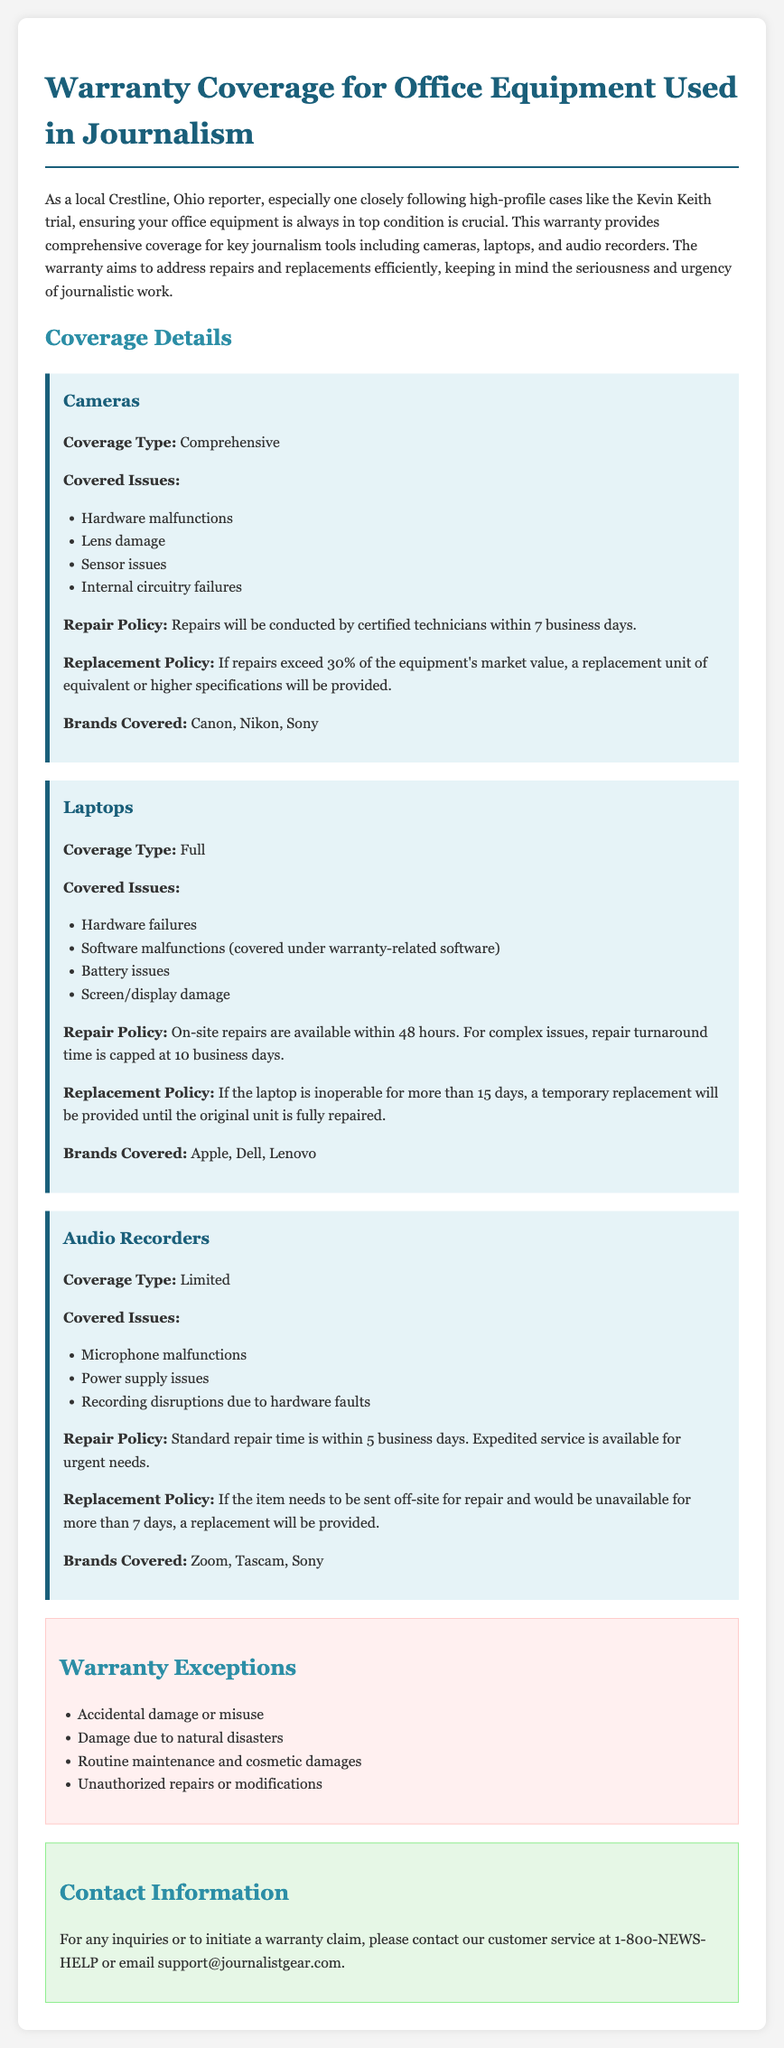what is the warranty coverage type for cameras? The document states that the coverage type for cameras is comprehensive.
Answer: comprehensive how many business days does it take for camera repairs? The repair policy for cameras mentions that repairs will be conducted within 7 business days.
Answer: 7 business days what brands are covered under the laptop warranty? The document lists the brands covered for laptops as Apple, Dell, and Lenovo.
Answer: Apple, Dell, Lenovo what is the maximum time for laptop repairs? For complex issues with laptops, the repair turnaround time is capped at 10 business days.
Answer: 10 business days how long will it take to replace a laptop if it is inoperable? The replacement policy states that a temporary replacement will be provided if the laptop is inoperable for more than 15 days.
Answer: 15 days what power supply issues are covered under audio recorders? The warranty for audio recorders covers power supply issues among other listed problems.
Answer: power supply issues what is one exception listed for the warranty coverage? The warranty exceptions include damage due to natural disasters.
Answer: damage due to natural disasters who should be contacted for warranty claims? For warranty claims, the document advises contacting customer service at 1-800-NEWS-HELP or emailing support@journalistgear.com.
Answer: 1-800-NEWS-HELP or support@journalistgear.com what is the repair time for audio recorders? The standard repair time for audio recorders is within 5 business days.
Answer: 5 business days 